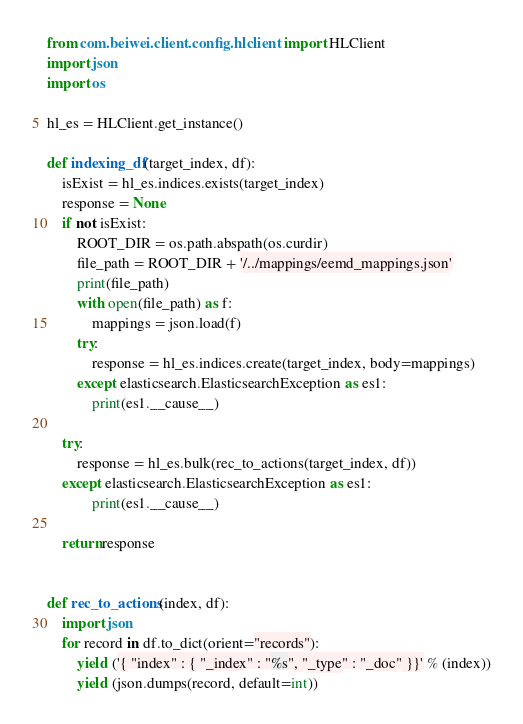<code> <loc_0><loc_0><loc_500><loc_500><_Python_>from com.beiwei.client.config.hlclient import HLClient
import json
import os

hl_es = HLClient.get_instance()

def indexing_df(target_index, df):
    isExist = hl_es.indices.exists(target_index)
    response = None
    if not isExist:
        ROOT_DIR = os.path.abspath(os.curdir)
        file_path = ROOT_DIR + '/../mappings/eemd_mappings.json'
        print(file_path)
        with open(file_path) as f:
            mappings = json.load(f)
        try:
            response = hl_es.indices.create(target_index, body=mappings)
        except elasticsearch.ElasticsearchException as es1:
            print(es1.__cause__)

    try:
        response = hl_es.bulk(rec_to_actions(target_index, df))
    except elasticsearch.ElasticsearchException as es1:
            print(es1.__cause__)

    return response


def rec_to_actions(index, df):
    import json
    for record in df.to_dict(orient="records"):
        yield ('{ "index" : { "_index" : "%s", "_type" : "_doc" }}' % (index))
        yield (json.dumps(record, default=int))

</code> 